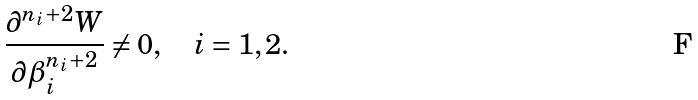Convert formula to latex. <formula><loc_0><loc_0><loc_500><loc_500>\frac { \partial ^ { n _ { i } + 2 } W } { \partial \beta _ { i } ^ { n _ { i } + 2 } } \neq 0 , \quad i = 1 , 2 .</formula> 